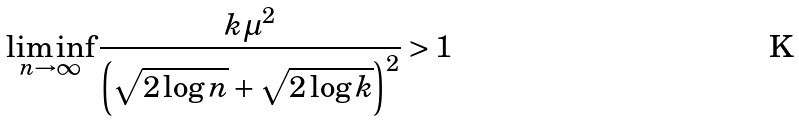<formula> <loc_0><loc_0><loc_500><loc_500>\liminf _ { n \to \infty } \frac { k \mu ^ { 2 } } { \left ( \sqrt { 2 \log n } + \sqrt { 2 \log k } \right ) ^ { 2 } } > 1</formula> 